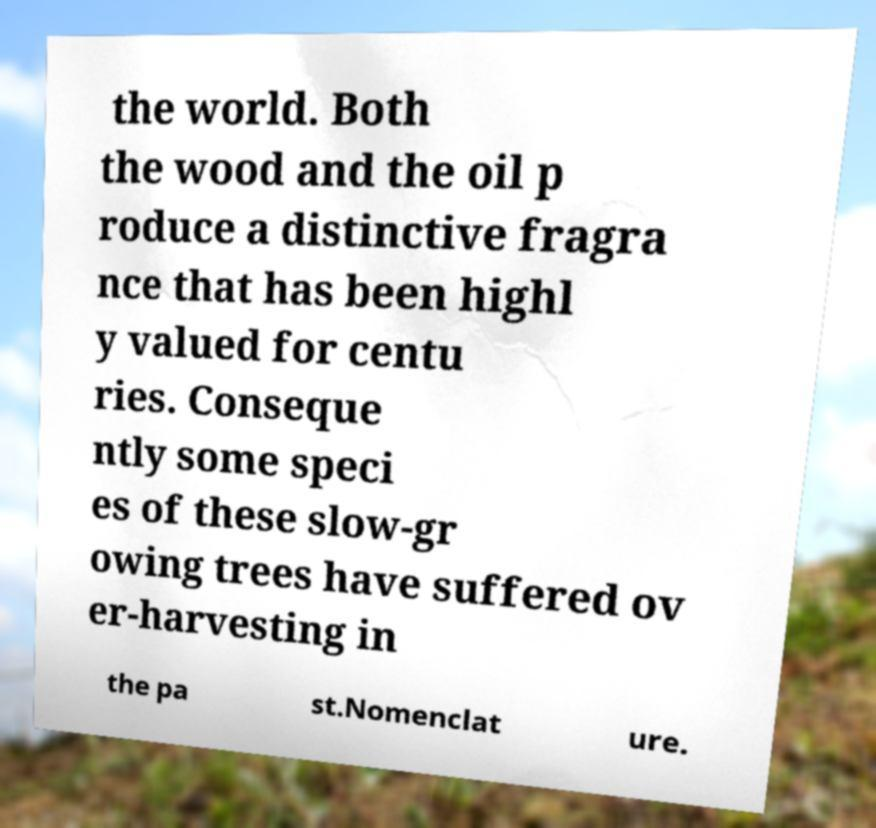Could you assist in decoding the text presented in this image and type it out clearly? the world. Both the wood and the oil p roduce a distinctive fragra nce that has been highl y valued for centu ries. Conseque ntly some speci es of these slow-gr owing trees have suffered ov er-harvesting in the pa st.Nomenclat ure. 